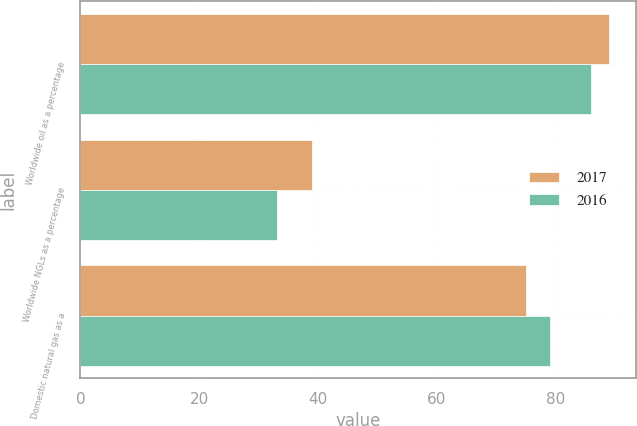Convert chart to OTSL. <chart><loc_0><loc_0><loc_500><loc_500><stacked_bar_chart><ecel><fcel>Worldwide oil as a percentage<fcel>Worldwide NGLs as a percentage<fcel>Domestic natural gas as a<nl><fcel>2017<fcel>89<fcel>39<fcel>75<nl><fcel>2016<fcel>86<fcel>33<fcel>79<nl></chart> 